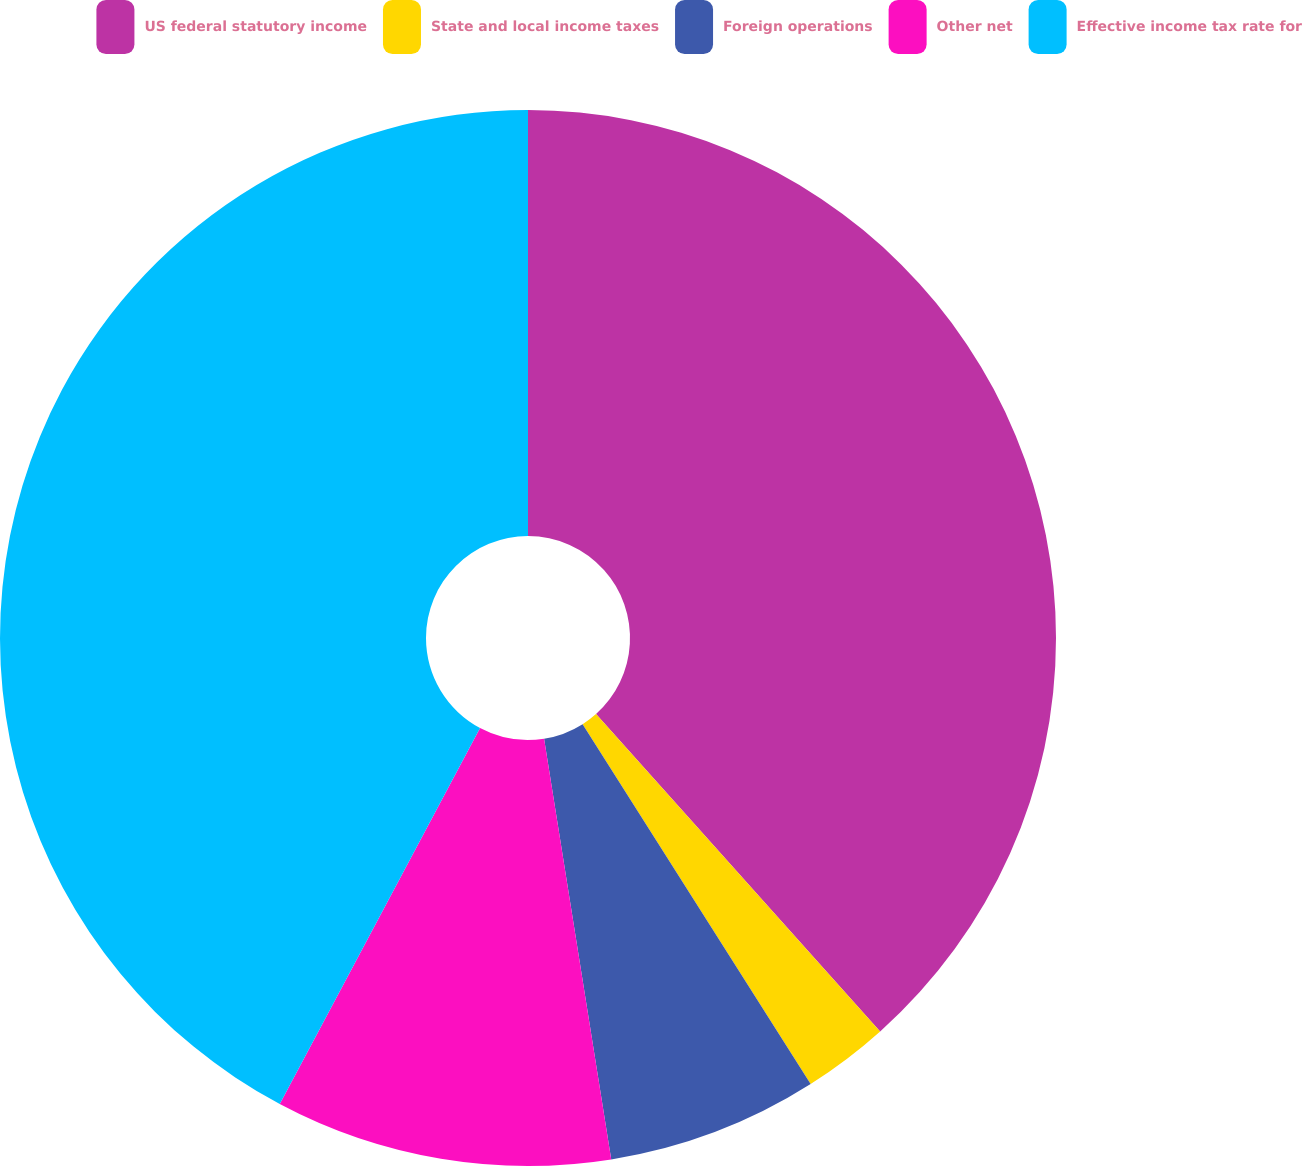Convert chart to OTSL. <chart><loc_0><loc_0><loc_500><loc_500><pie_chart><fcel>US federal statutory income<fcel>State and local income taxes<fcel>Foreign operations<fcel>Other net<fcel>Effective income tax rate for<nl><fcel>38.38%<fcel>2.63%<fcel>6.47%<fcel>10.31%<fcel>42.21%<nl></chart> 